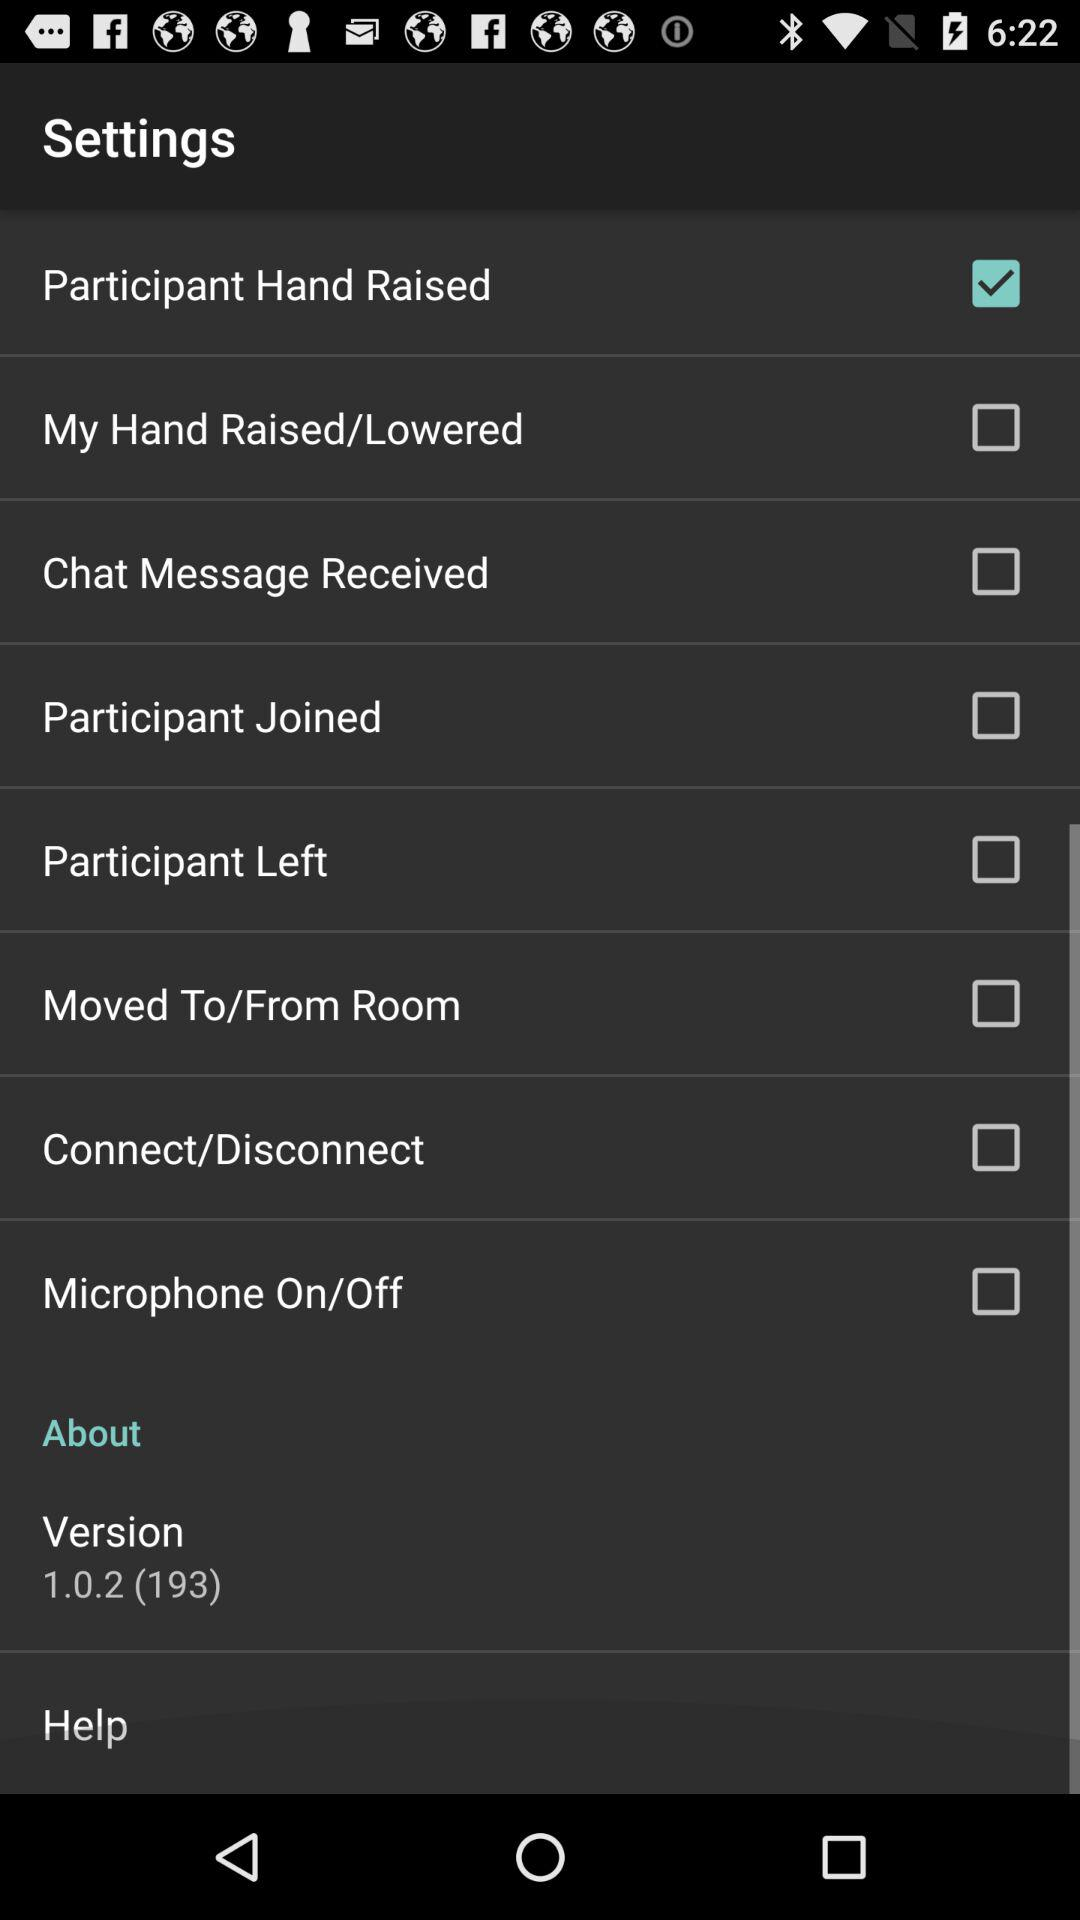What is the current status of "Participant Left"? The current status of "Participant Left" is "off". 